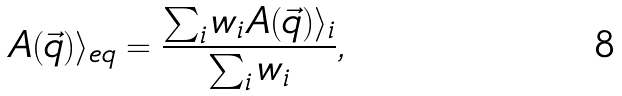<formula> <loc_0><loc_0><loc_500><loc_500>A ( \vec { q } ) \rangle _ { e q } = \frac { \sum _ { i } w _ { i } A ( \vec { q } ) \rangle _ { i } } { \sum _ { i } w _ { i } } ,</formula> 